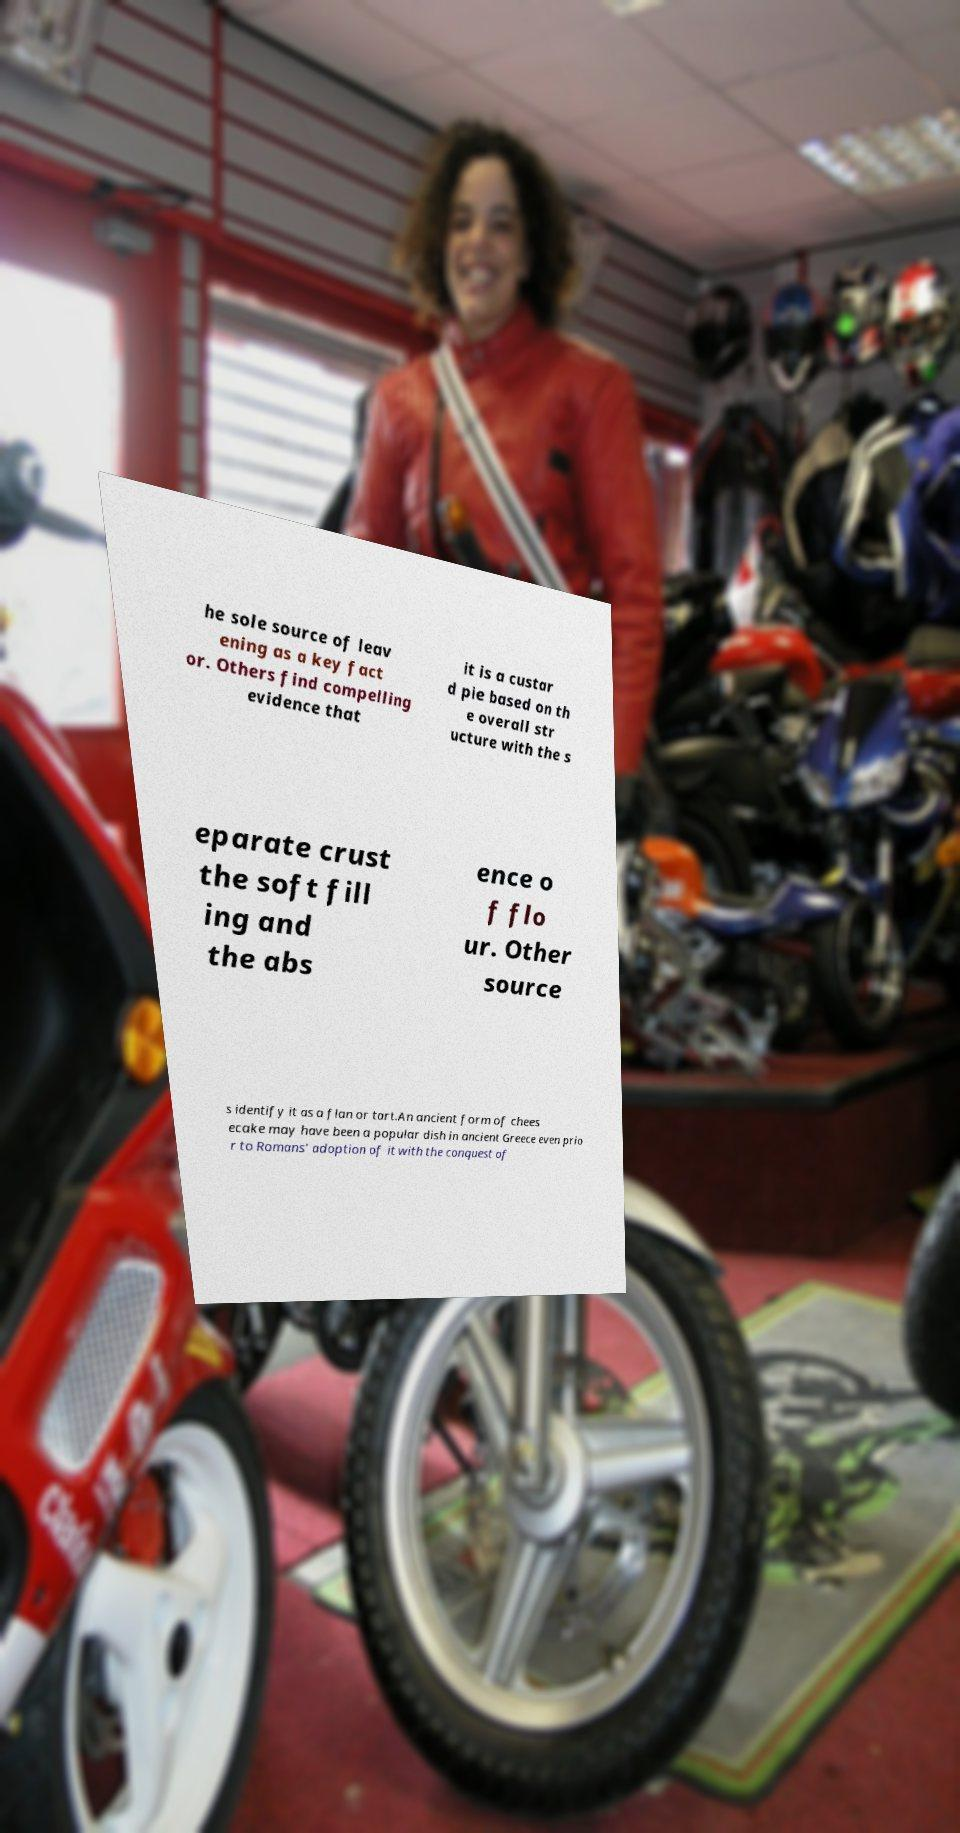Could you extract and type out the text from this image? he sole source of leav ening as a key fact or. Others find compelling evidence that it is a custar d pie based on th e overall str ucture with the s eparate crust the soft fill ing and the abs ence o f flo ur. Other source s identify it as a flan or tart.An ancient form of chees ecake may have been a popular dish in ancient Greece even prio r to Romans' adoption of it with the conquest of 